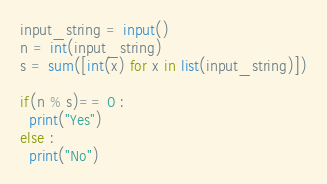Convert code to text. <code><loc_0><loc_0><loc_500><loc_500><_Python_>input_string = input()
n = int(input_string)
s = sum([int(x) for x in list(input_string)])

if(n % s)== 0 :
  print("Yes")
else :
  print("No")</code> 